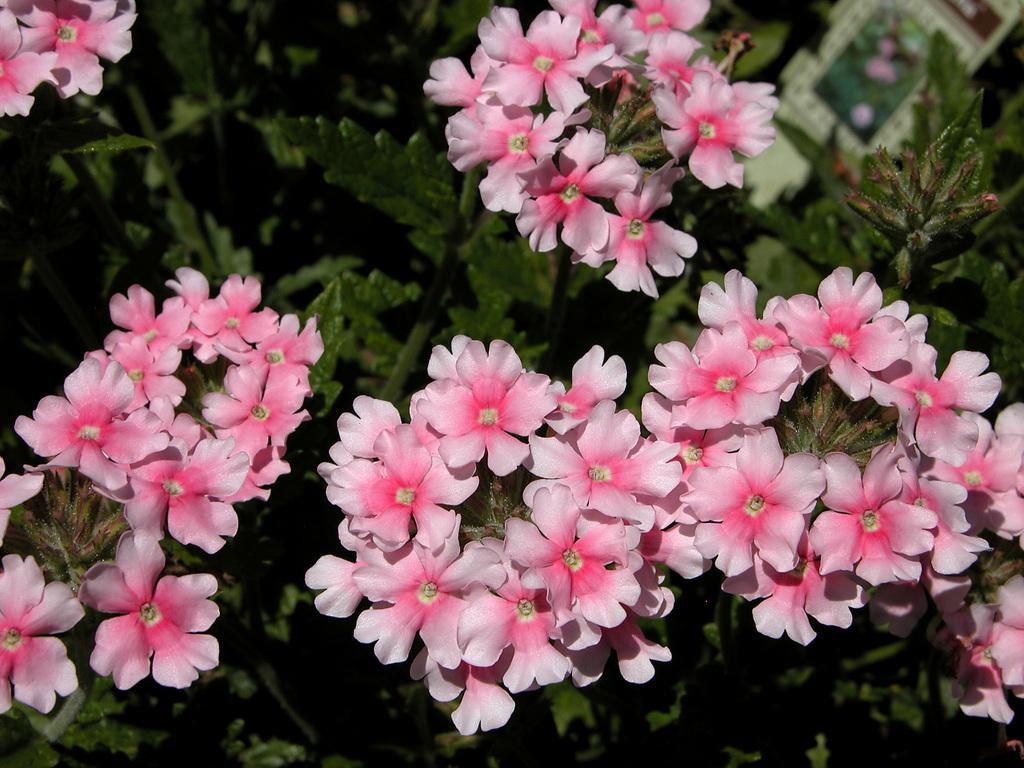Could you give a brief overview of what you see in this image? This image consists of flowers in pink color. In the background, there are plants. 